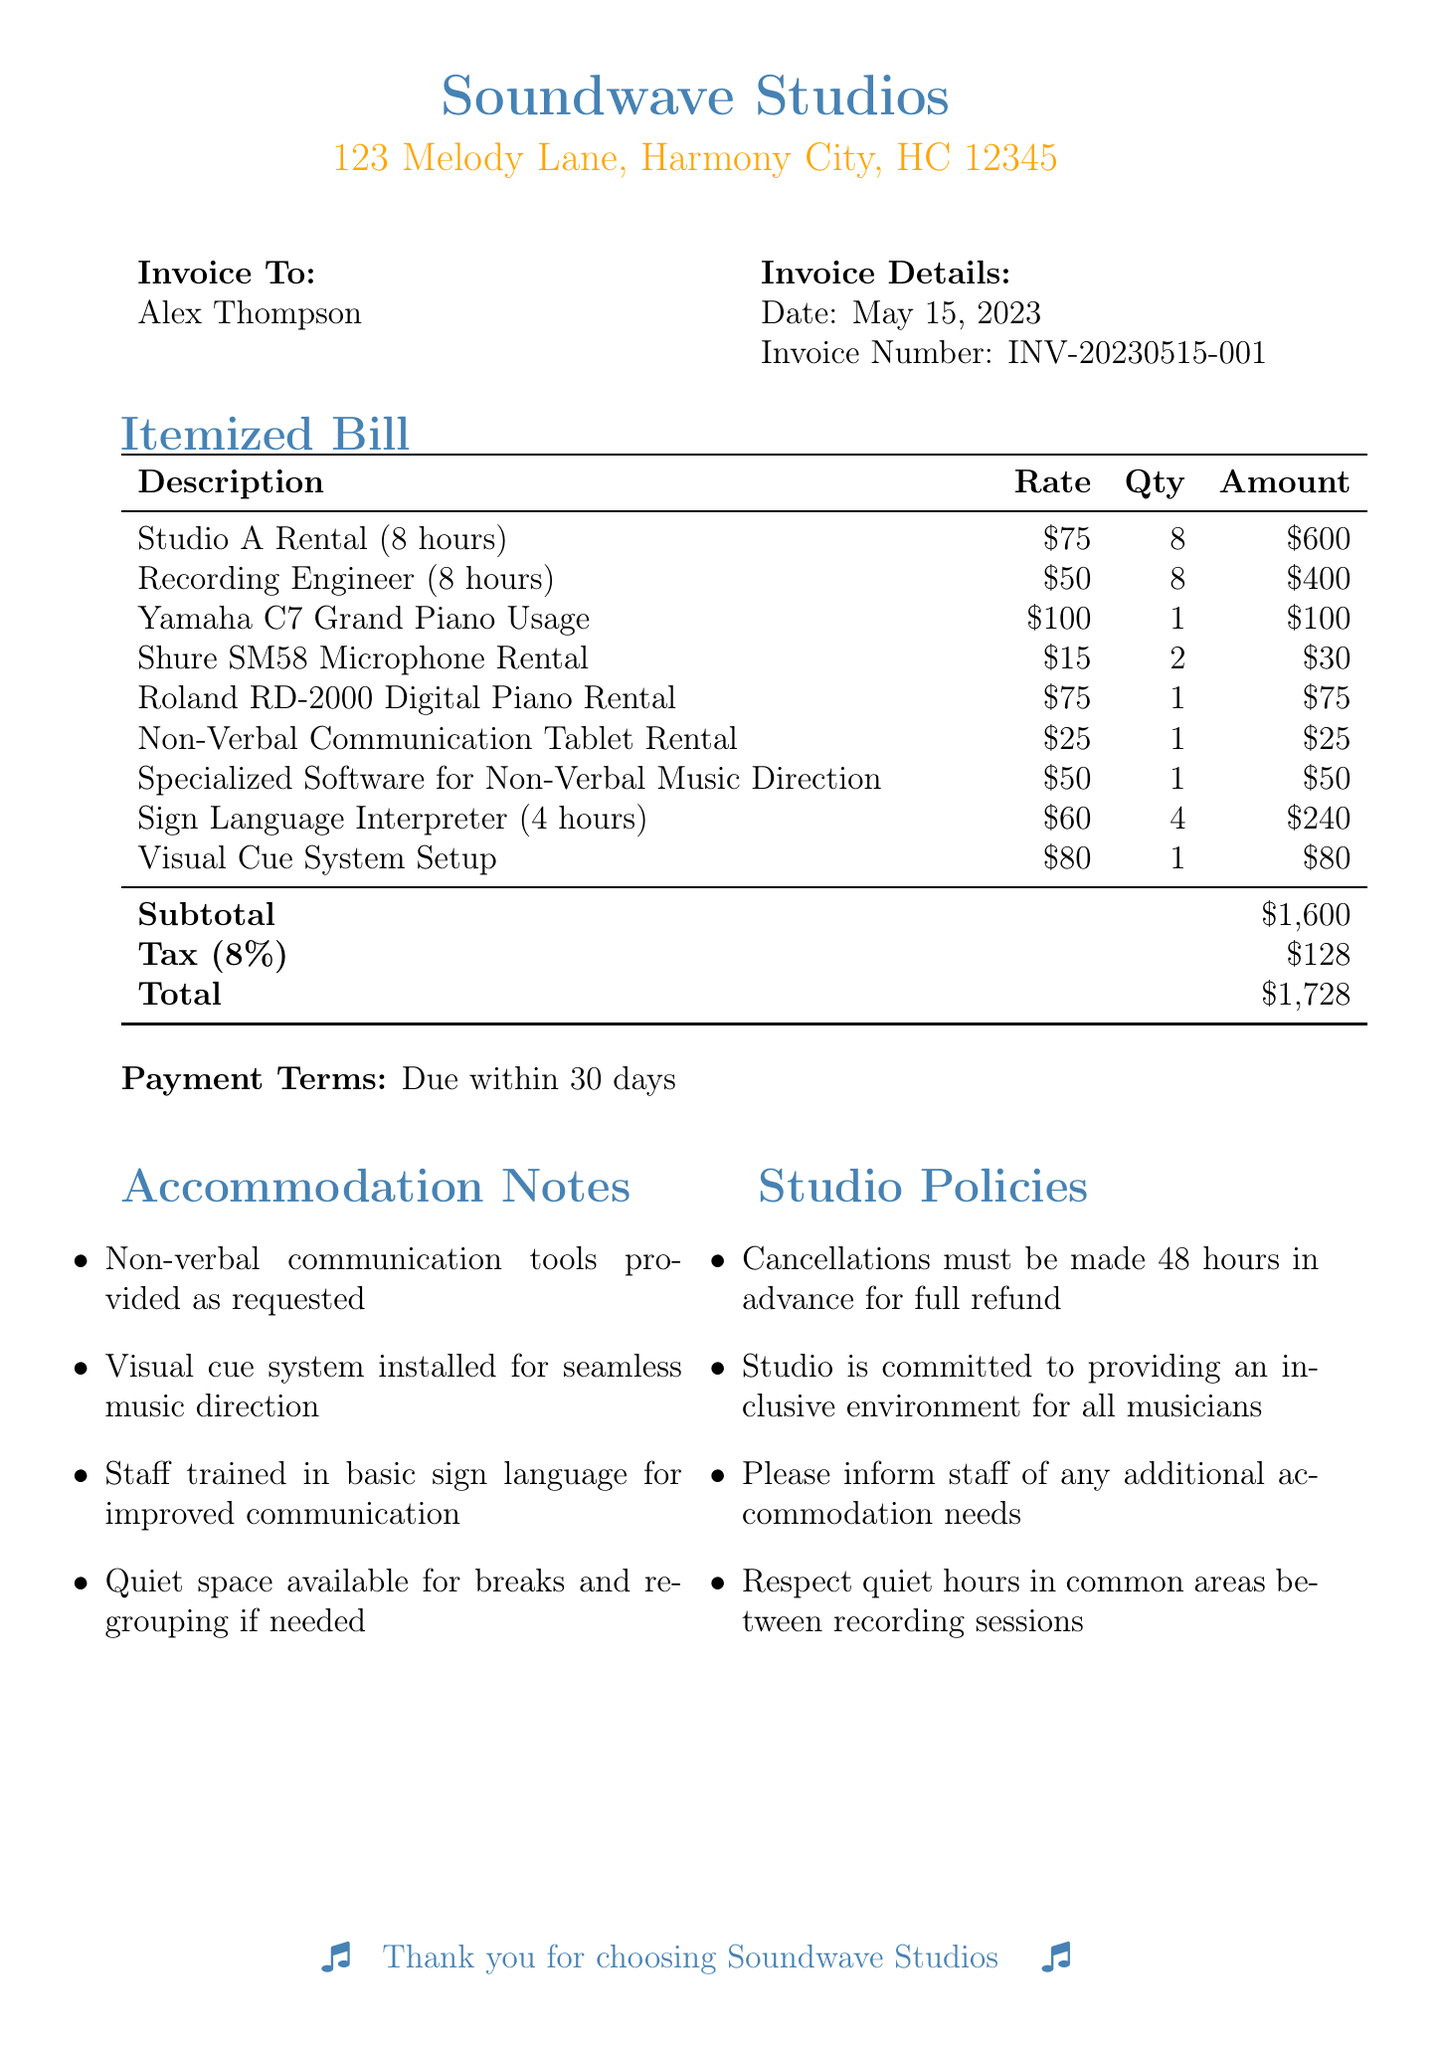What is the name of the studio? The studio name is listed at the top of the document as Soundwave Studios.
Answer: Soundwave Studios What is the date of the invoice? The date of the invoice can be found under the invoice details section as May 15, 2023.
Answer: May 15, 2023 How many hours was the Recording Engineer hired for? The line item for the Recording Engineer lists a quantity of 8 hours.
Answer: 8 hours What is the subtotal amount? The subtotal amount can be found at the bottom of the itemized bill, which shows $1,600.
Answer: $1,600 What accommodations are noted for non-verbal communication? The accommodation notes section mentions that non-verbal communication tools are provided as requested.
Answer: Non-verbal communication tools provided as requested What is the tax rate applied to the invoice? The document specifies the tax rate as 8% listed next to the tax amount.
Answer: 8% How many items were rented for non-verbal communication support? There are two items specifically supporting non-verbal communication mentioned in the invoice: the Non-Verbal Communication Tablet Rental and Specialized Software for Non-Verbal Music Direction.
Answer: 2 What is the payment term stated in the document? The payment terms are specified at the bottom of the document as "Due within 30 days."
Answer: Due within 30 days What is listed as a studio policy regarding cancellations? One of the studio policies states that cancellations must be made 48 hours in advance for a full refund.
Answer: 48 hours in advance How many hours was the Sign Language Interpreter hired for? The line item for the Sign Language Interpreter shows a quantity of 4 hours.
Answer: 4 hours 